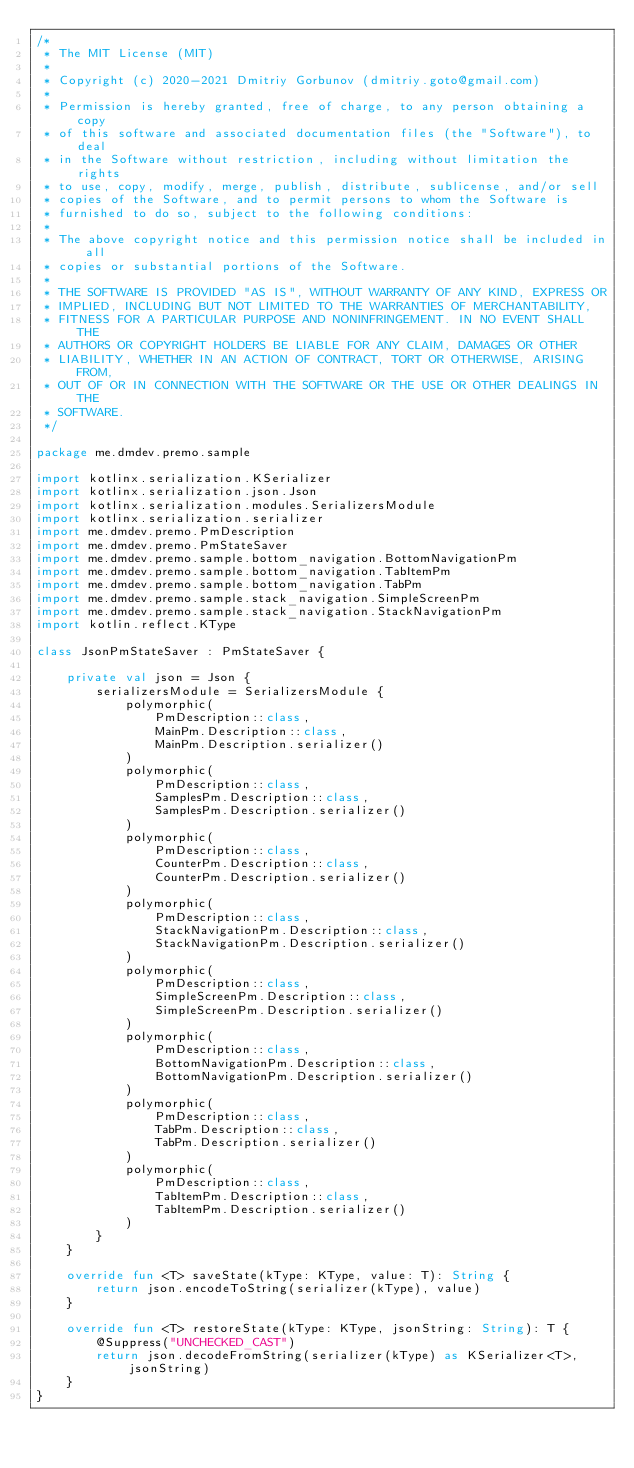<code> <loc_0><loc_0><loc_500><loc_500><_Kotlin_>/*
 * The MIT License (MIT)
 *
 * Copyright (c) 2020-2021 Dmitriy Gorbunov (dmitriy.goto@gmail.com)
 *
 * Permission is hereby granted, free of charge, to any person obtaining a copy
 * of this software and associated documentation files (the "Software"), to deal
 * in the Software without restriction, including without limitation the rights
 * to use, copy, modify, merge, publish, distribute, sublicense, and/or sell
 * copies of the Software, and to permit persons to whom the Software is
 * furnished to do so, subject to the following conditions:
 *
 * The above copyright notice and this permission notice shall be included in all
 * copies or substantial portions of the Software.
 *
 * THE SOFTWARE IS PROVIDED "AS IS", WITHOUT WARRANTY OF ANY KIND, EXPRESS OR
 * IMPLIED, INCLUDING BUT NOT LIMITED TO THE WARRANTIES OF MERCHANTABILITY,
 * FITNESS FOR A PARTICULAR PURPOSE AND NONINFRINGEMENT. IN NO EVENT SHALL THE
 * AUTHORS OR COPYRIGHT HOLDERS BE LIABLE FOR ANY CLAIM, DAMAGES OR OTHER
 * LIABILITY, WHETHER IN AN ACTION OF CONTRACT, TORT OR OTHERWISE, ARISING FROM,
 * OUT OF OR IN CONNECTION WITH THE SOFTWARE OR THE USE OR OTHER DEALINGS IN THE
 * SOFTWARE.
 */

package me.dmdev.premo.sample

import kotlinx.serialization.KSerializer
import kotlinx.serialization.json.Json
import kotlinx.serialization.modules.SerializersModule
import kotlinx.serialization.serializer
import me.dmdev.premo.PmDescription
import me.dmdev.premo.PmStateSaver
import me.dmdev.premo.sample.bottom_navigation.BottomNavigationPm
import me.dmdev.premo.sample.bottom_navigation.TabItemPm
import me.dmdev.premo.sample.bottom_navigation.TabPm
import me.dmdev.premo.sample.stack_navigation.SimpleScreenPm
import me.dmdev.premo.sample.stack_navigation.StackNavigationPm
import kotlin.reflect.KType

class JsonPmStateSaver : PmStateSaver {

    private val json = Json {
        serializersModule = SerializersModule {
            polymorphic(
                PmDescription::class,
                MainPm.Description::class,
                MainPm.Description.serializer()
            )
            polymorphic(
                PmDescription::class,
                SamplesPm.Description::class,
                SamplesPm.Description.serializer()
            )
            polymorphic(
                PmDescription::class,
                CounterPm.Description::class,
                CounterPm.Description.serializer()
            )
            polymorphic(
                PmDescription::class,
                StackNavigationPm.Description::class,
                StackNavigationPm.Description.serializer()
            )
            polymorphic(
                PmDescription::class,
                SimpleScreenPm.Description::class,
                SimpleScreenPm.Description.serializer()
            )
            polymorphic(
                PmDescription::class,
                BottomNavigationPm.Description::class,
                BottomNavigationPm.Description.serializer()
            )
            polymorphic(
                PmDescription::class,
                TabPm.Description::class,
                TabPm.Description.serializer()
            )
            polymorphic(
                PmDescription::class,
                TabItemPm.Description::class,
                TabItemPm.Description.serializer()
            )
        }
    }

    override fun <T> saveState(kType: KType, value: T): String {
        return json.encodeToString(serializer(kType), value)
    }

    override fun <T> restoreState(kType: KType, jsonString: String): T {
        @Suppress("UNCHECKED_CAST")
        return json.decodeFromString(serializer(kType) as KSerializer<T>, jsonString)
    }
}</code> 